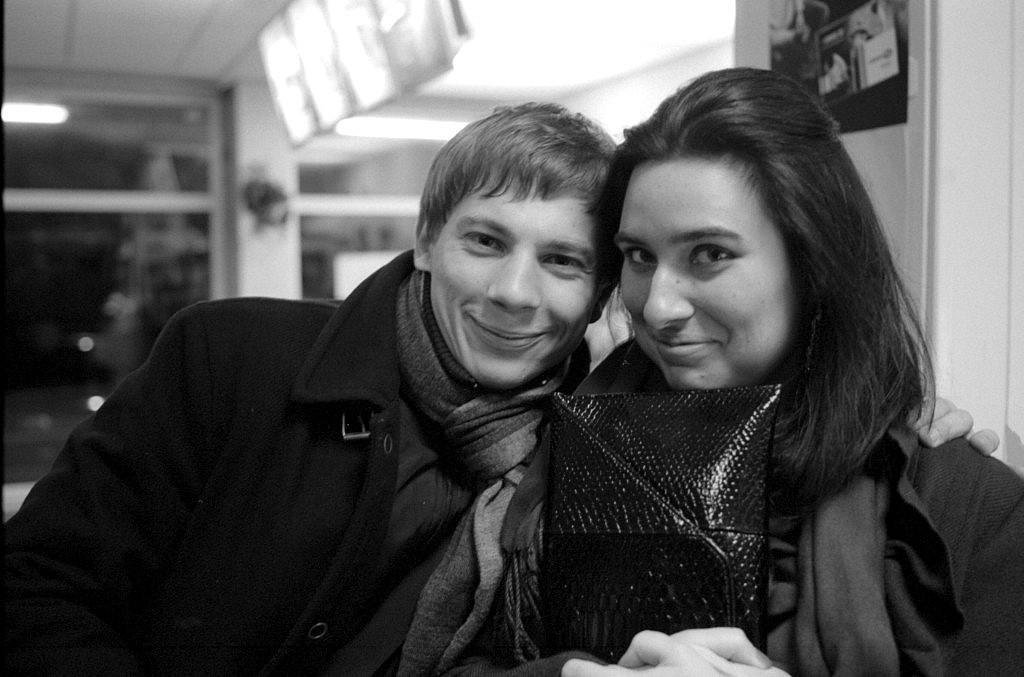Describe this image in one or two sentences. In this image I see a black and white image and I see a man and a woman and I see that both of them are smiling. In the background I see a poster over here and I see the wall and I see the lights and I see that it is a bit blurred in the background. 